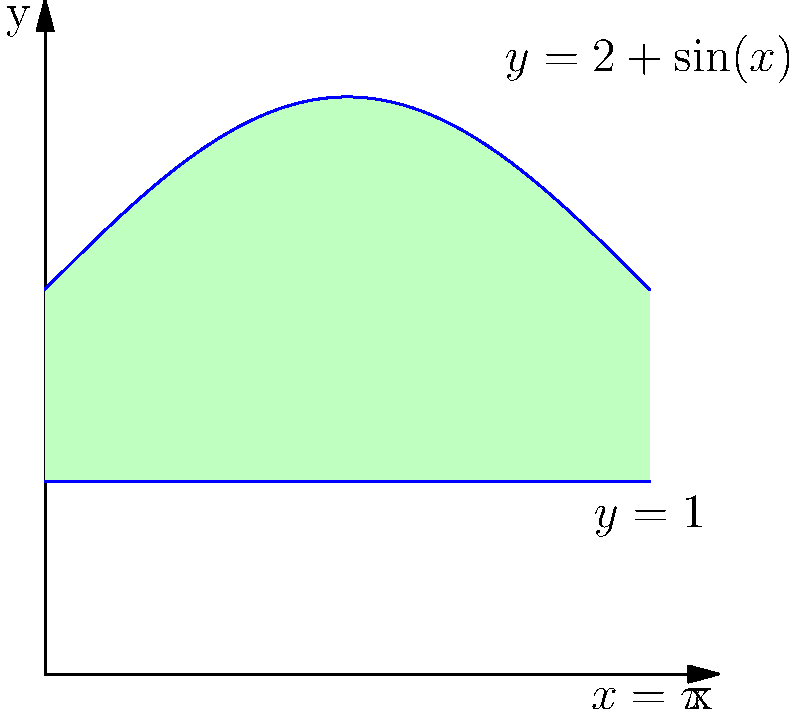As part of a philanthropic initiative, your pet store chain is designing a unique water fountain for a local animal shelter. The cross-sectional area of the fountain is modeled by the region bounded by the curves $y=2+\sin(x)$, $y=1$, and $x=\pi$. If the fountain is to be 5 feet long, what volume of water (in cubic feet) can it hold when filled to capacity? Round your answer to two decimal places. To find the volume of the water fountain, we need to use the method of cylindrical shells:

1) The volume is given by the integral: $V = 2\pi \int_0^{\pi} x[f(x)-g(x)]dx$

   Where $f(x)=2+\sin(x)$ and $g(x)=1$

2) Substituting these into our integral:
   $V = 2\pi \int_0^{\pi} x[(2+\sin(x))-1]dx$
   $V = 2\pi \int_0^{\pi} x[1+\sin(x)]dx$

3) Using integration by parts, let $u=x$ and $dv=\sin(x)dx$:
   $V = 2\pi [\int_0^{\pi} x dx + \int_0^{\pi} x\sin(x)dx]$
   $V = 2\pi [\frac{x^2}{2}|_0^{\pi} - \int_0^{\pi} (-x\cos(x) + \sin(x))dx]$

4) Evaluating:
   $V = 2\pi [\frac{\pi^2}{2} + x\cos(x)|_0^{\pi} - \int_0^{\pi} \sin(x)dx]$
   $V = 2\pi [\frac{\pi^2}{2} + \pi\cos(\pi) - \cos(x)|_0^{\pi}]$
   $V = 2\pi [\frac{\pi^2}{2} - \pi + 2]$

5) Simplifying:
   $V = \pi^3 - 2\pi^2 + 4\pi \approx 5.92$ cubic feet

6) The question asks for the volume when the fountain is 5 feet long, so we need to scale our result:
   $V_{total} = 5 \cdot 5.92 = 29.60$ cubic feet

Therefore, the fountain can hold approximately 29.60 cubic feet of water.
Answer: 29.60 cubic feet 